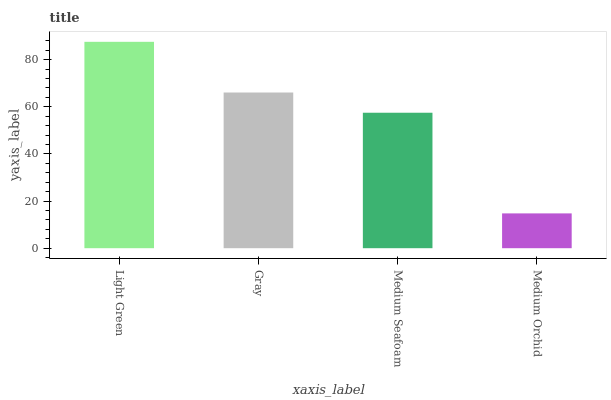Is Medium Orchid the minimum?
Answer yes or no. Yes. Is Light Green the maximum?
Answer yes or no. Yes. Is Gray the minimum?
Answer yes or no. No. Is Gray the maximum?
Answer yes or no. No. Is Light Green greater than Gray?
Answer yes or no. Yes. Is Gray less than Light Green?
Answer yes or no. Yes. Is Gray greater than Light Green?
Answer yes or no. No. Is Light Green less than Gray?
Answer yes or no. No. Is Gray the high median?
Answer yes or no. Yes. Is Medium Seafoam the low median?
Answer yes or no. Yes. Is Medium Seafoam the high median?
Answer yes or no. No. Is Medium Orchid the low median?
Answer yes or no. No. 